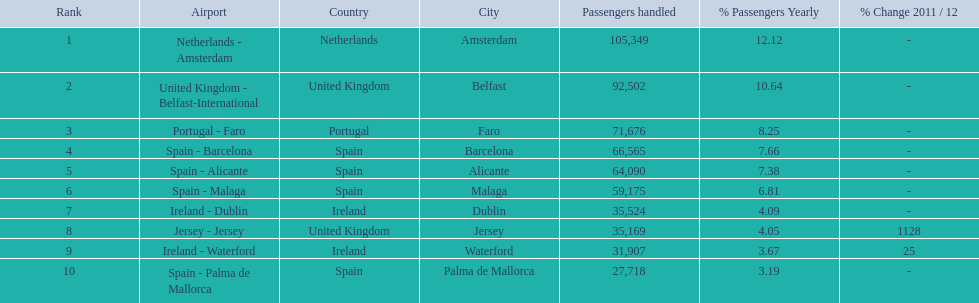What is the best rank? 1. What is the airport? Netherlands - Amsterdam. 